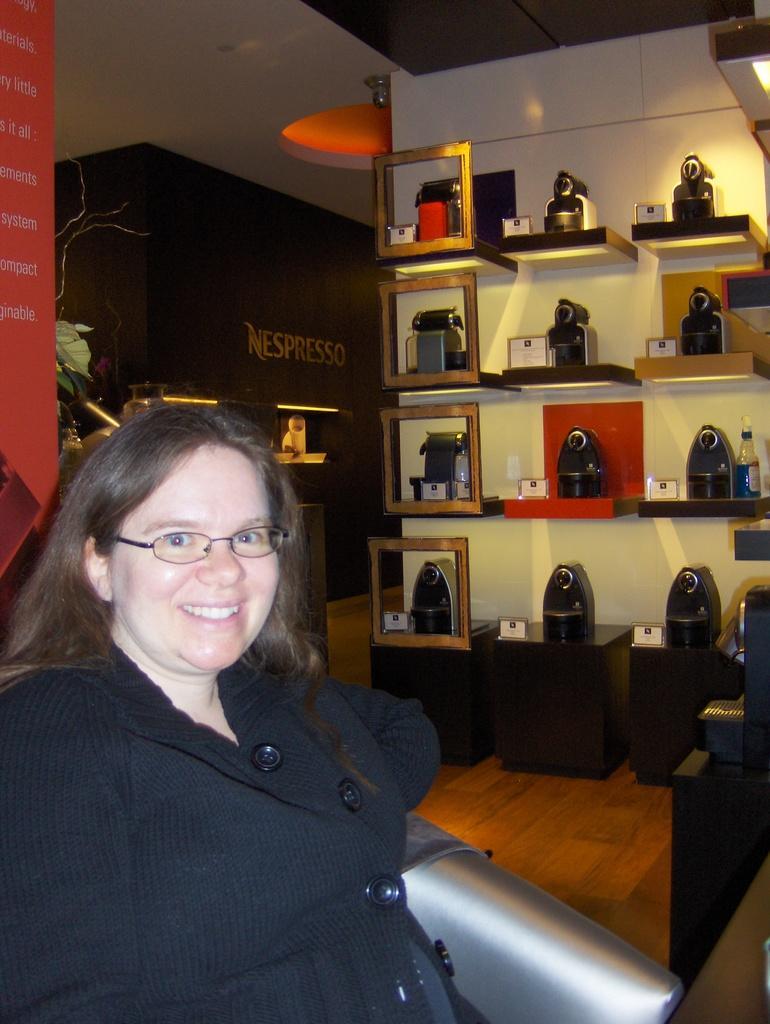Could you give a brief overview of what you see in this image? In this image I can see a woman is smiling. The woman is wearing black color clothes and spectacles. In the background I can see some objects and white color wall. On the left side I can see something written on a black color object. Here I can see lights. 